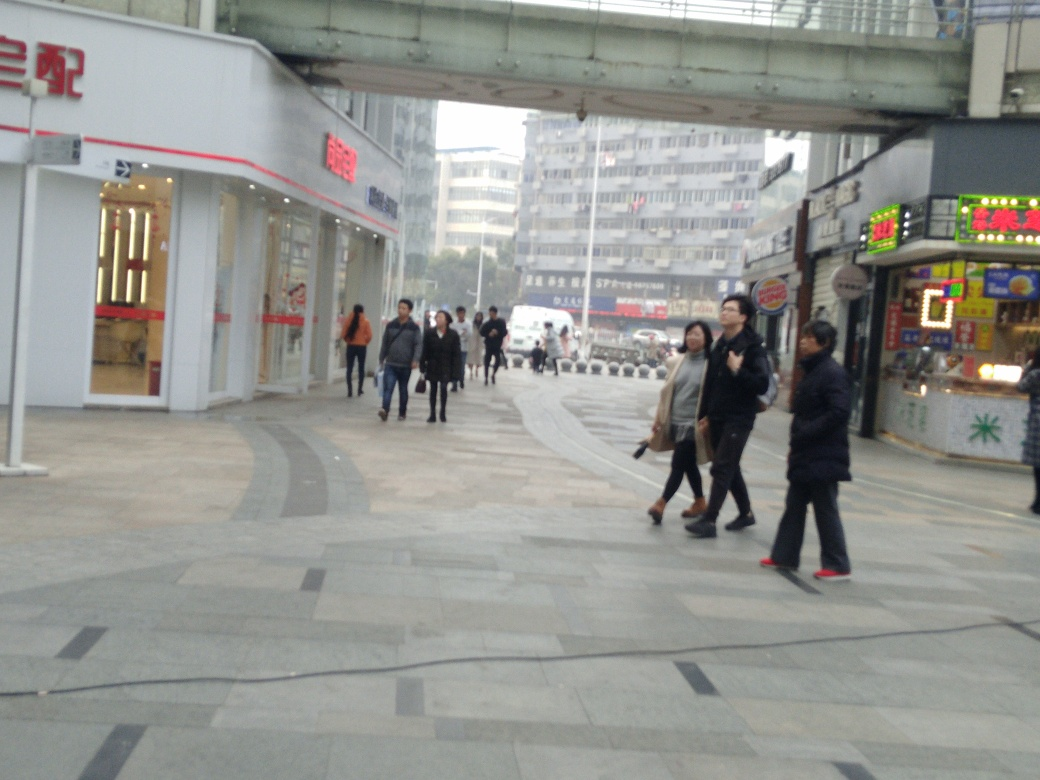Is there too much content in the overall image? The image isn't overly cluttered; it offers a balanced level of detail, portraying an urban street scene with a mix of pedestrians, storefronts, and infrastructure. However, assessments of content density can be subjective and depend on the specific context or intent behind the question. 